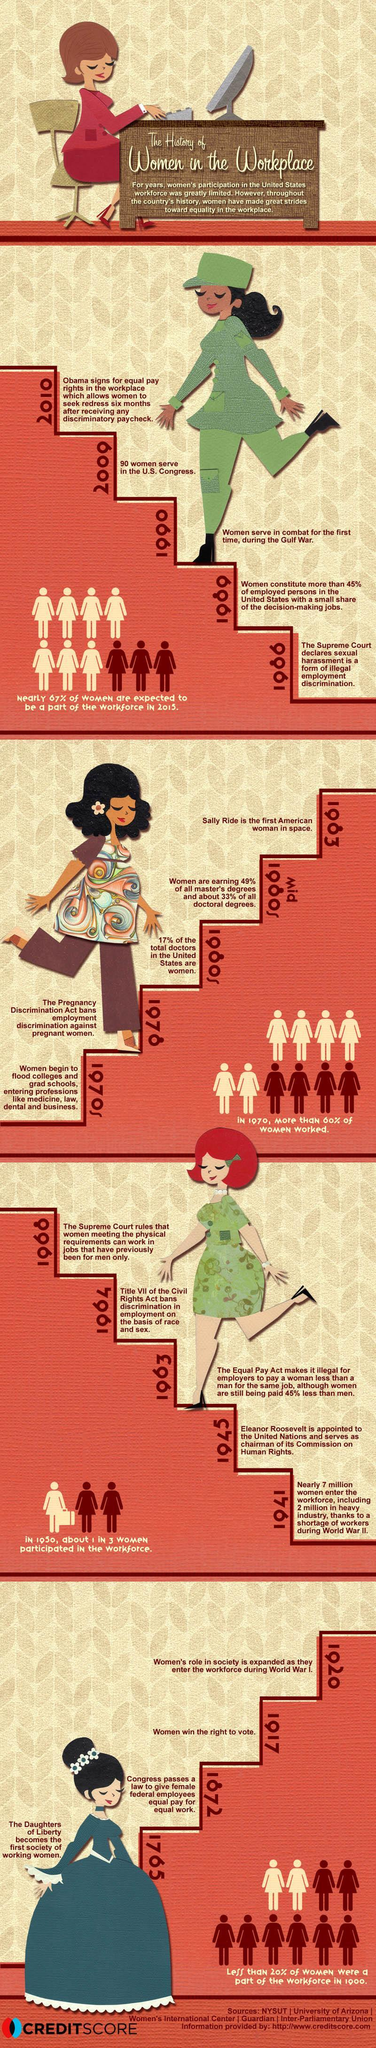When did women in the U.S. get the right to vote?
Answer the question with a short phrase. 1917 When did U.S. women serve in combat for the first time during the Gulf war? 1990 